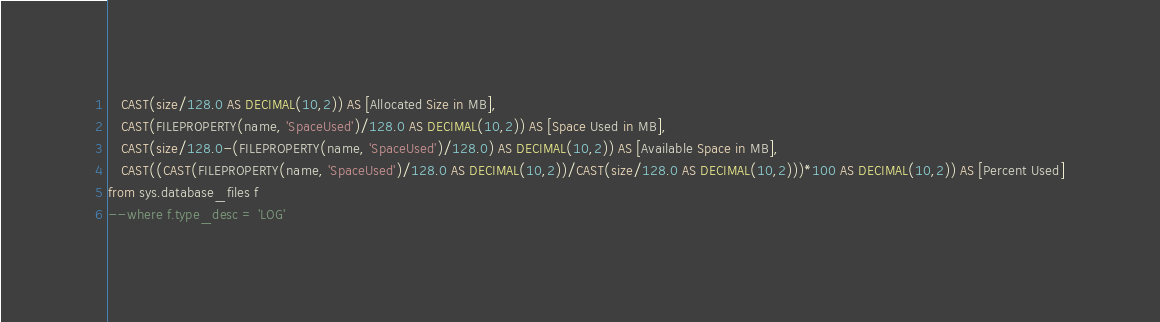Convert code to text. <code><loc_0><loc_0><loc_500><loc_500><_SQL_>   CAST(size/128.0 AS DECIMAL(10,2)) AS [Allocated Size in MB],
   CAST(FILEPROPERTY(name, 'SpaceUsed')/128.0 AS DECIMAL(10,2)) AS [Space Used in MB],
   CAST(size/128.0-(FILEPROPERTY(name, 'SpaceUsed')/128.0) AS DECIMAL(10,2)) AS [Available Space in MB],
   CAST((CAST(FILEPROPERTY(name, 'SpaceUsed')/128.0 AS DECIMAL(10,2))/CAST(size/128.0 AS DECIMAL(10,2)))*100 AS DECIMAL(10,2)) AS [Percent Used]
from sys.database_files f 
--where f.type_desc = 'LOG'
</code> 